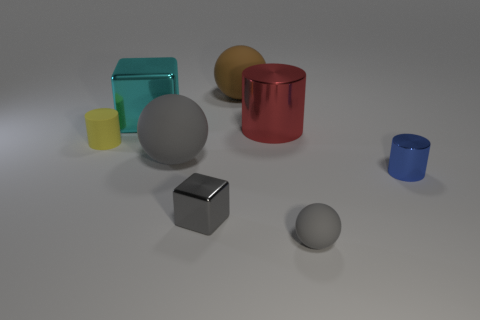Do the gray metallic cube and the rubber sphere that is behind the large cyan shiny object have the same size?
Keep it short and to the point. No. What size is the cylinder right of the gray matte sphere that is to the right of the cube that is in front of the big gray rubber sphere?
Offer a very short reply. Small. Is there a large yellow shiny sphere?
Your answer should be very brief. No. There is a cube that is the same color as the tiny matte sphere; what material is it?
Make the answer very short. Metal. What number of big matte things are the same color as the tiny ball?
Give a very brief answer. 1. What number of objects are either rubber objects that are in front of the big red cylinder or balls that are to the left of the red object?
Your answer should be very brief. 4. How many gray rubber spheres are behind the big cylinder that is to the left of the tiny blue cylinder?
Make the answer very short. 0. What color is the other large thing that is made of the same material as the large cyan object?
Your answer should be very brief. Red. Is there a block that has the same size as the blue object?
Ensure brevity in your answer.  Yes. The shiny object that is the same size as the blue cylinder is what shape?
Give a very brief answer. Cube. 